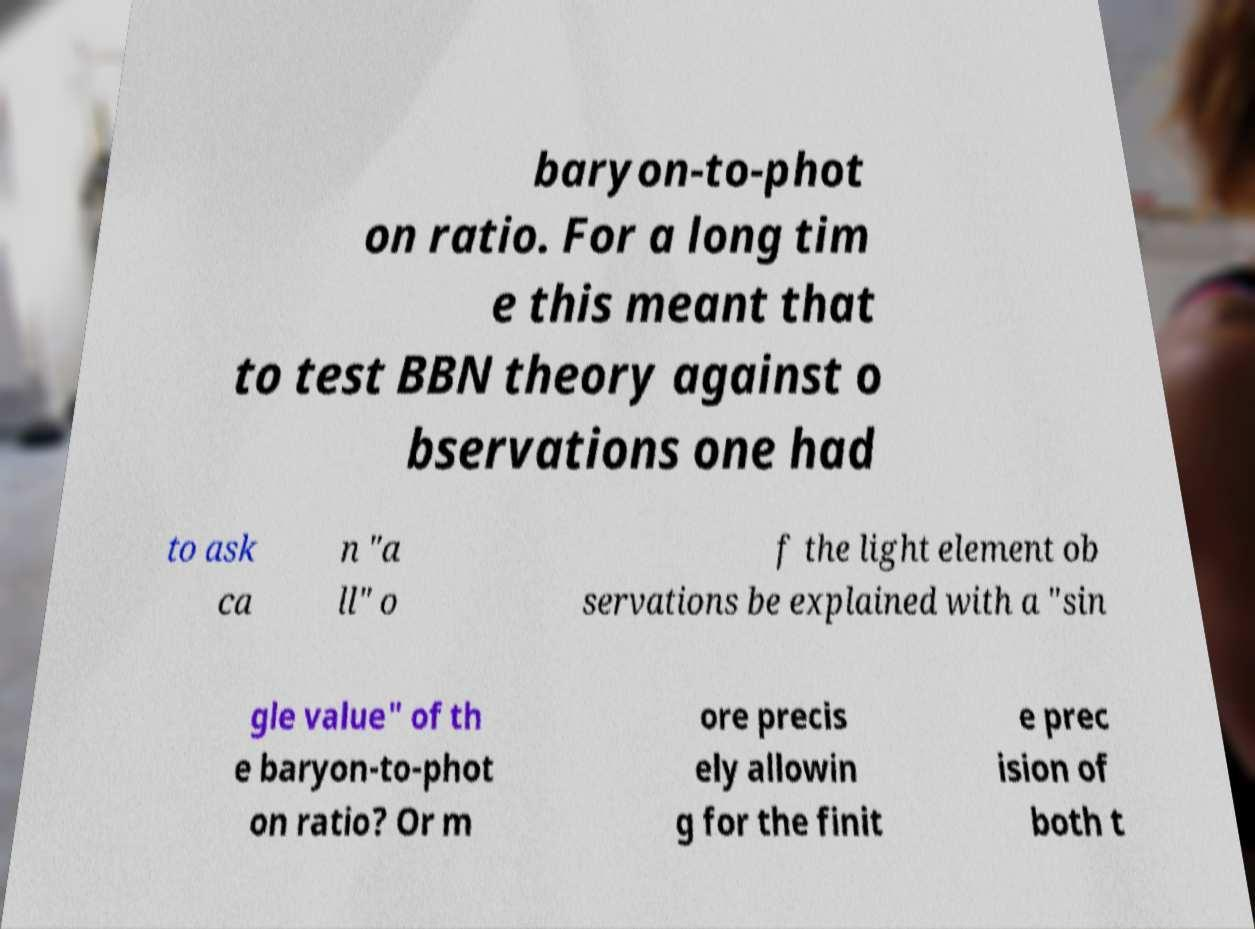I need the written content from this picture converted into text. Can you do that? baryon-to-phot on ratio. For a long tim e this meant that to test BBN theory against o bservations one had to ask ca n "a ll" o f the light element ob servations be explained with a "sin gle value" of th e baryon-to-phot on ratio? Or m ore precis ely allowin g for the finit e prec ision of both t 